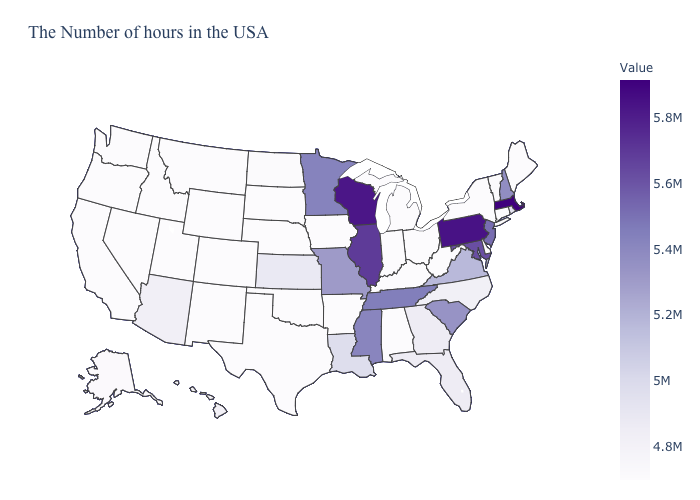Does Maryland have the highest value in the South?
Give a very brief answer. Yes. Which states have the lowest value in the USA?
Quick response, please. Maine, Connecticut, New York, Delaware, West Virginia, Ohio, Michigan, Kentucky, Indiana, Alabama, Arkansas, Iowa, Nebraska, Oklahoma, Texas, South Dakota, Wyoming, Colorado, New Mexico, Utah, Montana, Idaho, Nevada, California, Washington, Oregon. Does the map have missing data?
Short answer required. No. 